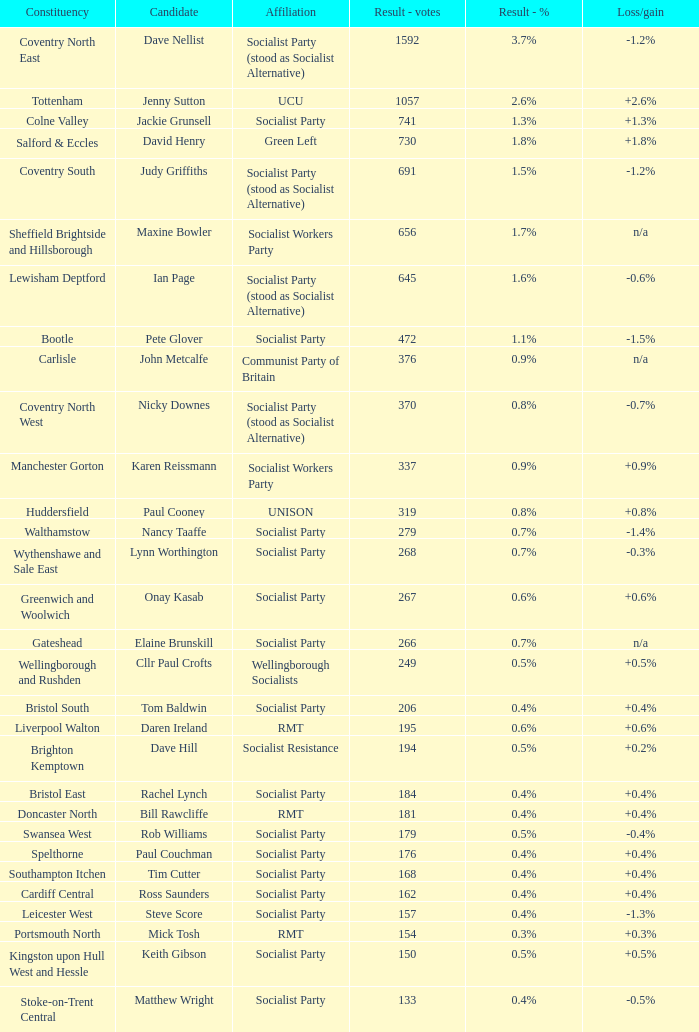What is the largest vote result for the Huddersfield constituency? 319.0. 